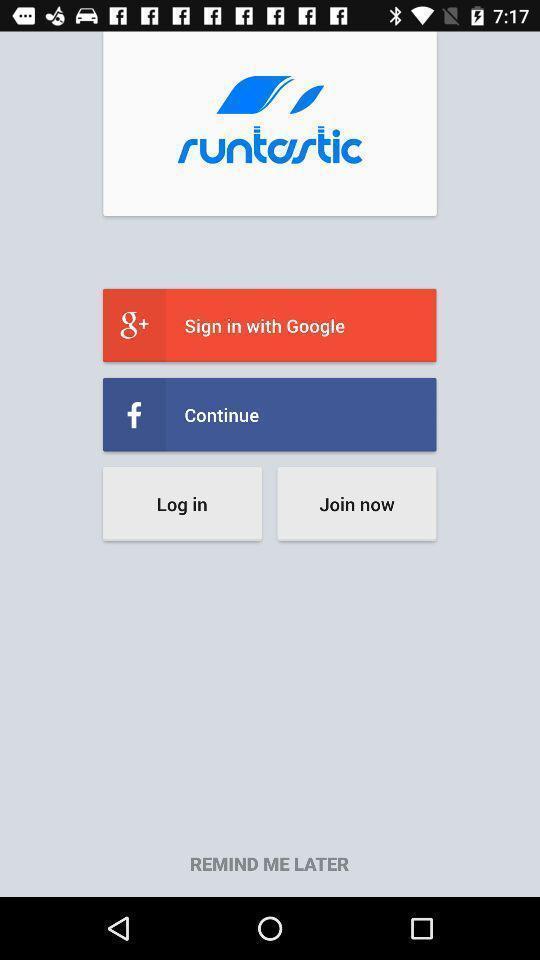What details can you identify in this image? Welcome page. 